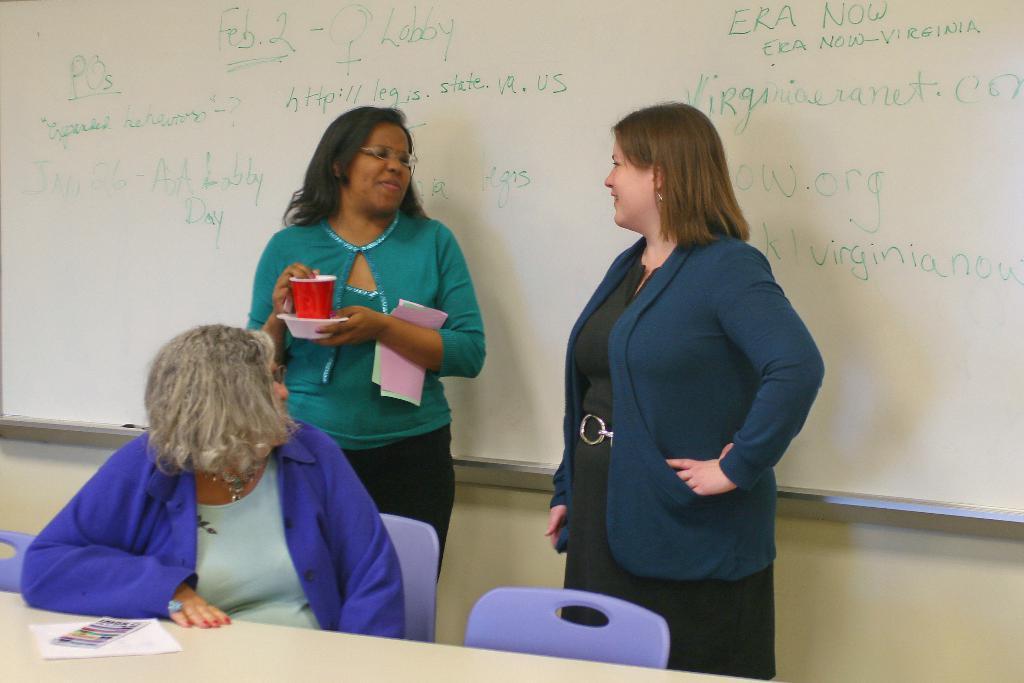Describe this image in one or two sentences. In the foreground of the picture there are women, table, book, paper and chairs. In the background it is board. 